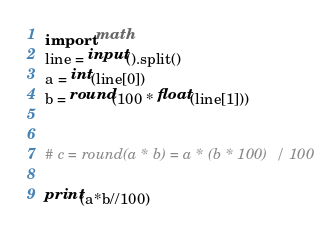<code> <loc_0><loc_0><loc_500><loc_500><_Python_>import math
line = input().split()
a = int(line[0])
b = round(100 * float(line[1]))


# c = round(a * b) = a * (b * 100)  / 100

print(a*b//100)</code> 